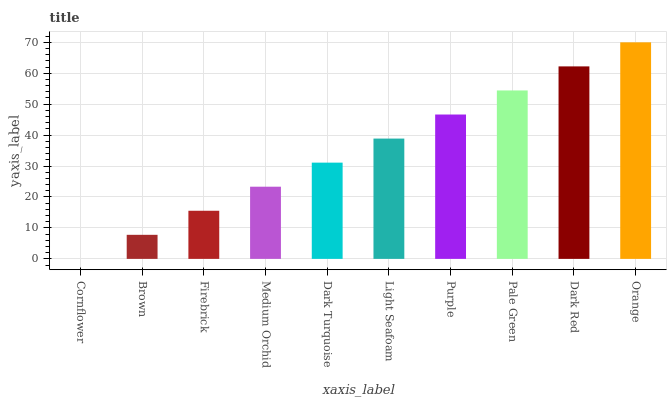Is Cornflower the minimum?
Answer yes or no. Yes. Is Orange the maximum?
Answer yes or no. Yes. Is Brown the minimum?
Answer yes or no. No. Is Brown the maximum?
Answer yes or no. No. Is Brown greater than Cornflower?
Answer yes or no. Yes. Is Cornflower less than Brown?
Answer yes or no. Yes. Is Cornflower greater than Brown?
Answer yes or no. No. Is Brown less than Cornflower?
Answer yes or no. No. Is Light Seafoam the high median?
Answer yes or no. Yes. Is Dark Turquoise the low median?
Answer yes or no. Yes. Is Dark Red the high median?
Answer yes or no. No. Is Firebrick the low median?
Answer yes or no. No. 